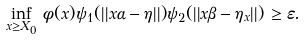Convert formula to latex. <formula><loc_0><loc_0><loc_500><loc_500>\inf _ { x \geq X _ { 0 } } \, \phi ( x ) \psi _ { 1 } ( | | x \alpha - \eta | | ) \psi _ { 2 } ( | | x \beta - \eta _ { x } | | ) \, \geq \varepsilon .</formula> 